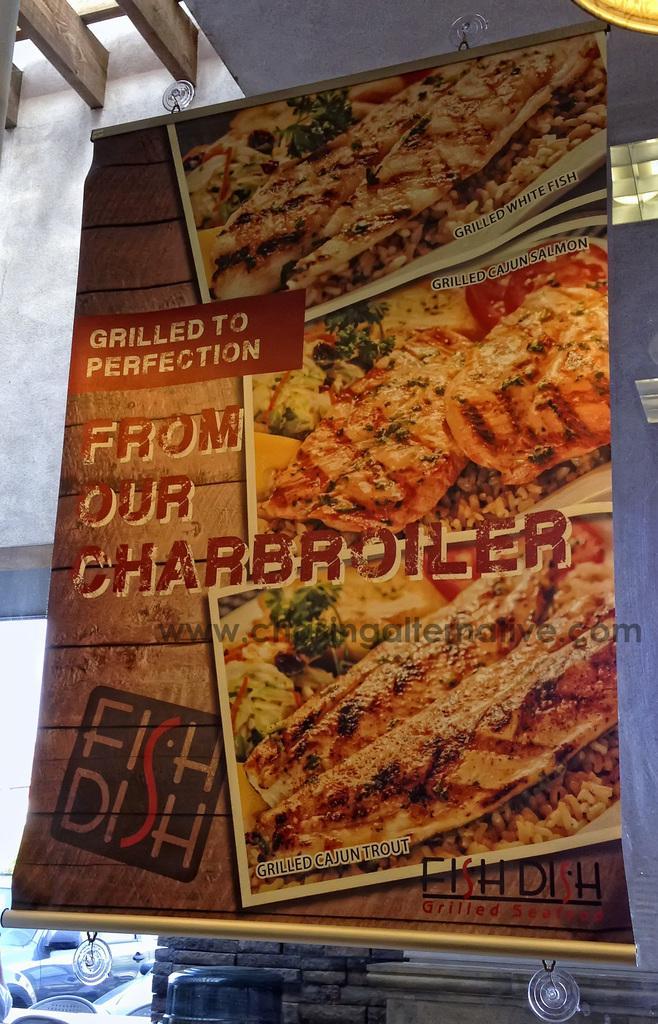Can you describe this image briefly? In this image I can see the banner which is orange, brown and black in color is hanged to the white colored surface. In the background I can see the wall and few other objects. 